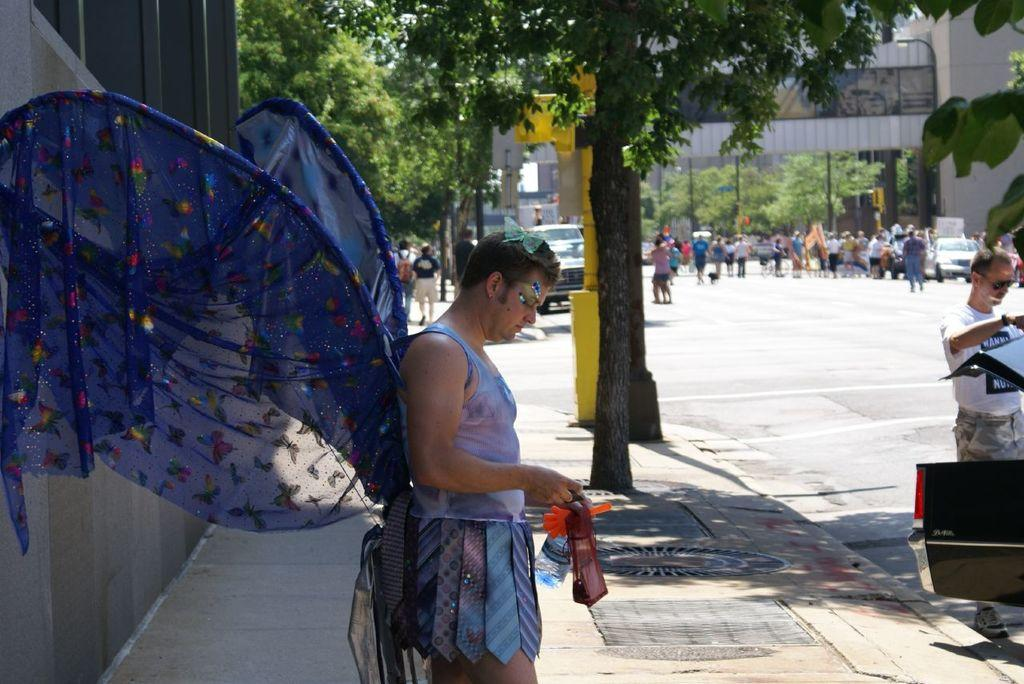How many people are in the image? There are two persons standing in the image. What is one of the persons holding? One person is holding a bottle and other objects. What can be seen in the background of the image? There are trees, persons, vehicles, and a wall visible in the background of the image. Can you describe the setting of the image? The image appears to be set outdoors, with a wall and trees in the background, and a road with vehicles. How many baby deer can be seen playing with a hen in the image? There are no baby deer or hens present in the image. 